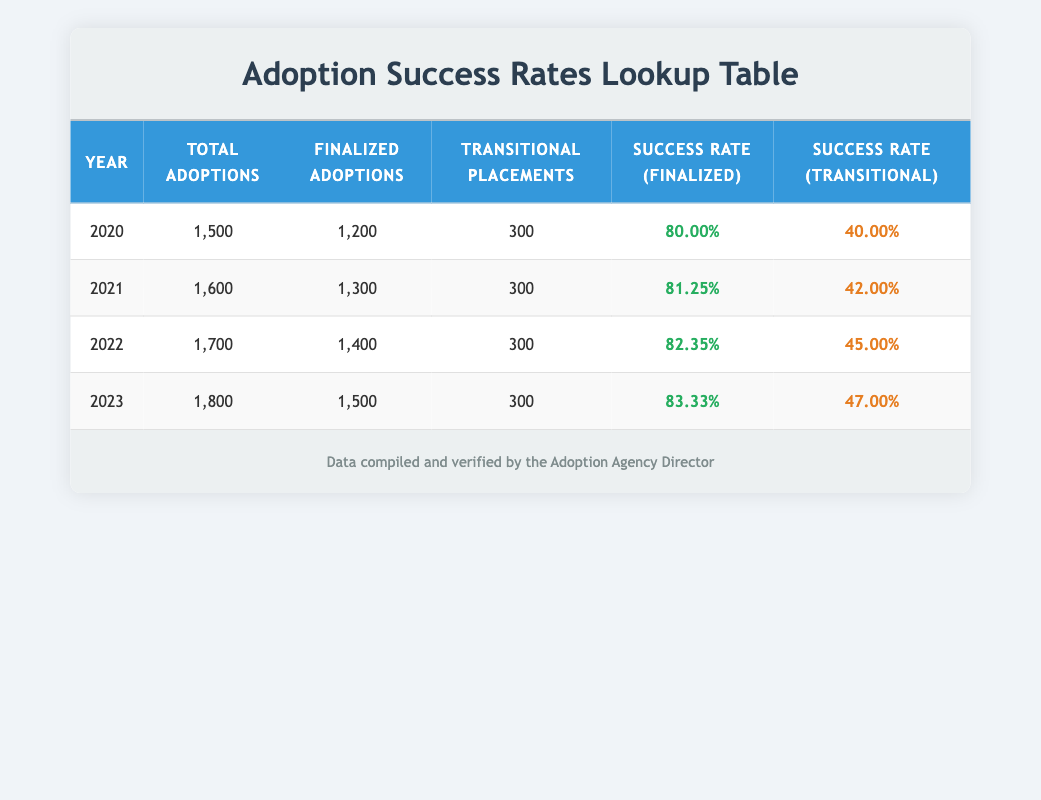What was the success rate for finalized adoptions in 2021? The table shows that in 2021, the success rate for finalized adoptions is 81.25%.
Answer: 81.25% How many total adoptions were there in 2022? According to the table, there were 1,700 total adoptions in 2022.
Answer: 1,700 What is the difference between the success rates of finalized adoptions in 2023 and transitional placements in 2020? The success rate for finalized adoptions in 2023 is 83.33%, and for transitional placements in 2020, it is 40.00%. The difference is 83.33% - 40.00% = 43.33%.
Answer: 43.33% Is the success rate for transitional placements in 2022 greater than the success rate for finalized adoptions in 2020? The success rate for transitional placements in 2022 is 45.00%, which is greater than the success rate for finalized adoptions in 2020, which is 80.00%. Therefore, the statement is false.
Answer: No What is the average success rate for finalized adoptions from 2020 to 2023? To find the average, add the success rates for finalized adoptions from each year: (80.00 + 81.25 + 82.35 + 83.33) / 4 = 81.48. Thus, the average success rate for finalized adoptions from 2020 to 2023 is 81.48%.
Answer: 81.48% 